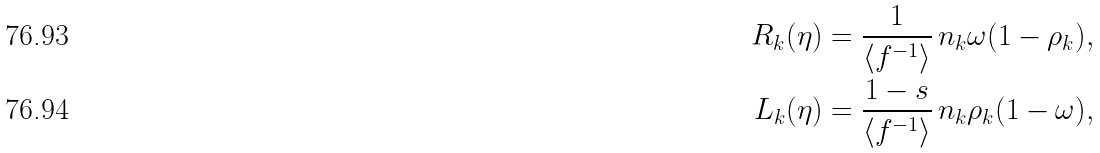<formula> <loc_0><loc_0><loc_500><loc_500>R _ { k } ( \eta ) & = \frac { 1 } { \langle f ^ { - 1 } \rangle } \, n _ { k } \omega ( 1 - \rho _ { k } ) , \\ L _ { k } ( \eta ) & = \frac { 1 - s } { \langle f ^ { - 1 } \rangle } \, n _ { k } \rho _ { k } ( 1 - \omega ) ,</formula> 